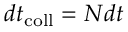Convert formula to latex. <formula><loc_0><loc_0><loc_500><loc_500>d t _ { c o l l } = N d t</formula> 